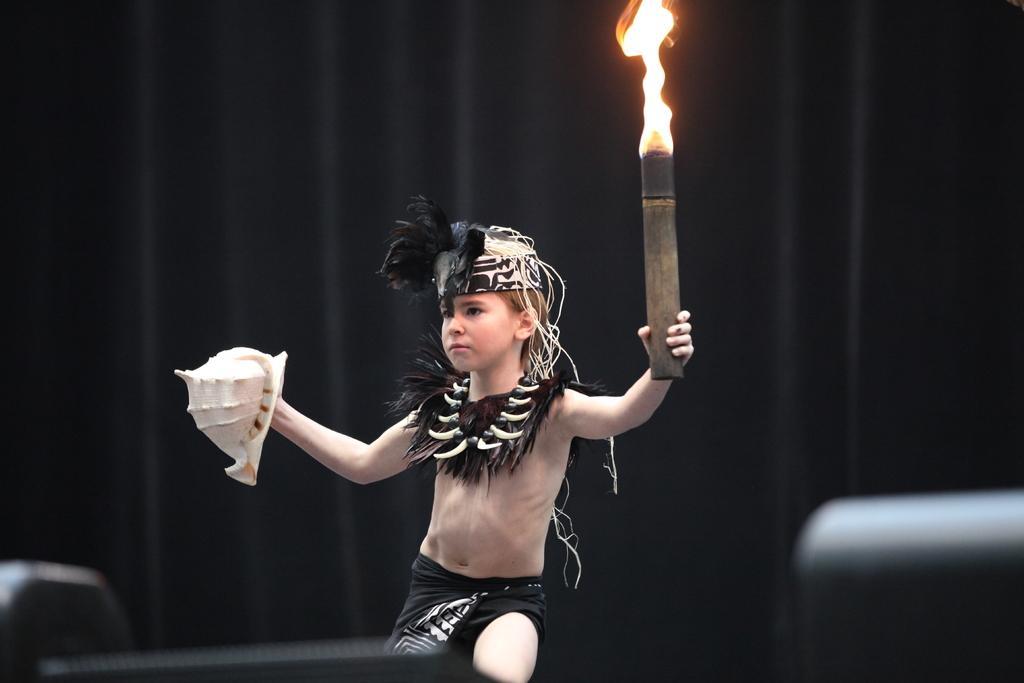In one or two sentences, can you explain what this image depicts? In this picture, we can see a child holding some objects, we can see the blurred background, and some objects in the bottom left and right side of the picture. 